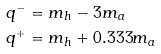Convert formula to latex. <formula><loc_0><loc_0><loc_500><loc_500>& q ^ { - } = m _ { h } - 3 m _ { a } \\ & q ^ { + } = m _ { h } + 0 . 3 3 3 m _ { a }</formula> 